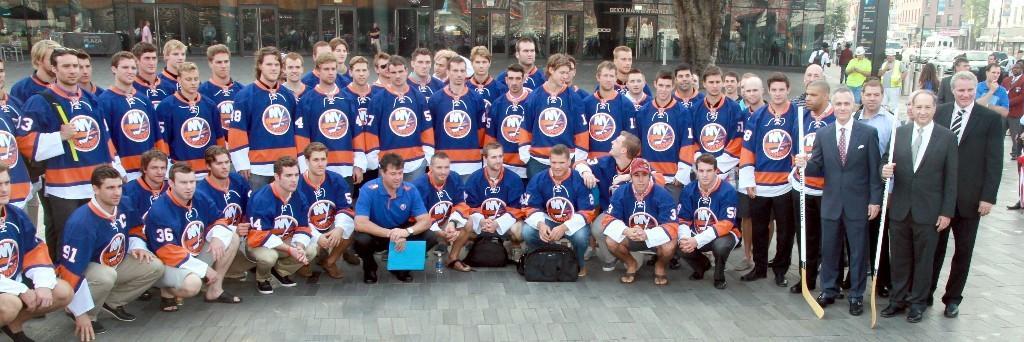Could you give a brief overview of what you see in this image? In this image, we can see some people standing and some people are in squat position, at the right side there are some people standing and holding stocks, in the background we can see some cars and there are some buildings. 